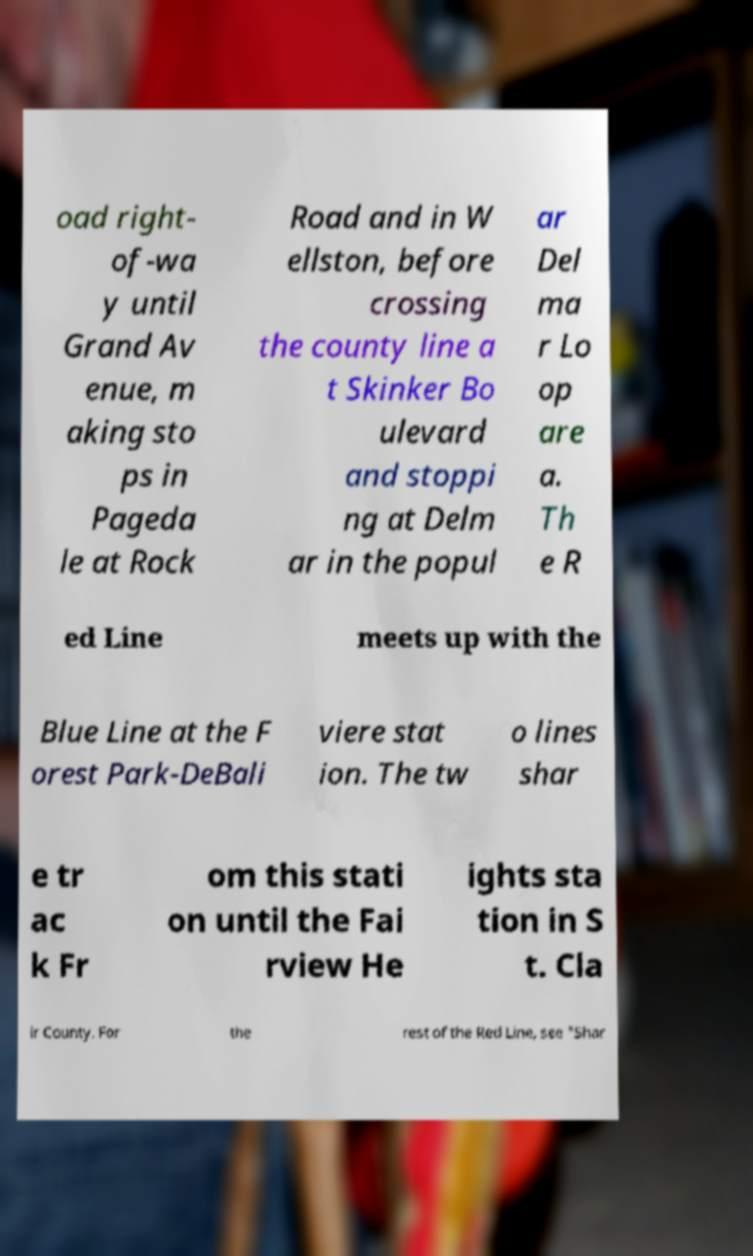For documentation purposes, I need the text within this image transcribed. Could you provide that? oad right- of-wa y until Grand Av enue, m aking sto ps in Pageda le at Rock Road and in W ellston, before crossing the county line a t Skinker Bo ulevard and stoppi ng at Delm ar in the popul ar Del ma r Lo op are a. Th e R ed Line meets up with the Blue Line at the F orest Park-DeBali viere stat ion. The tw o lines shar e tr ac k Fr om this stati on until the Fai rview He ights sta tion in S t. Cla ir County. For the rest of the Red Line, see "Shar 